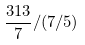Convert formula to latex. <formula><loc_0><loc_0><loc_500><loc_500>\frac { 3 1 3 } { 7 } / ( 7 / 5 )</formula> 